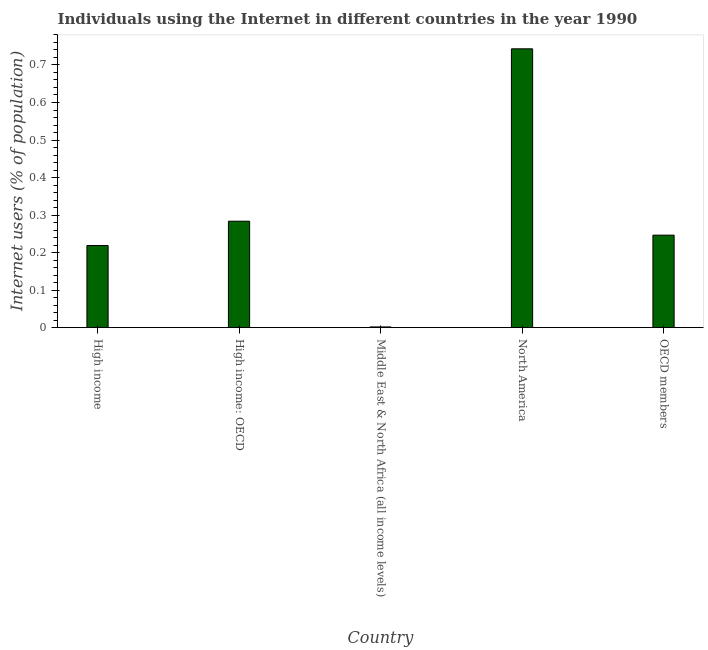Does the graph contain grids?
Make the answer very short. No. What is the title of the graph?
Give a very brief answer. Individuals using the Internet in different countries in the year 1990. What is the label or title of the X-axis?
Offer a terse response. Country. What is the label or title of the Y-axis?
Keep it short and to the point. Internet users (% of population). What is the number of internet users in Middle East & North Africa (all income levels)?
Your response must be concise. 0. Across all countries, what is the maximum number of internet users?
Ensure brevity in your answer.  0.74. Across all countries, what is the minimum number of internet users?
Keep it short and to the point. 0. In which country was the number of internet users maximum?
Offer a very short reply. North America. In which country was the number of internet users minimum?
Keep it short and to the point. Middle East & North Africa (all income levels). What is the sum of the number of internet users?
Ensure brevity in your answer.  1.49. What is the difference between the number of internet users in High income and OECD members?
Offer a terse response. -0.03. What is the average number of internet users per country?
Offer a terse response. 0.3. What is the median number of internet users?
Offer a terse response. 0.25. What is the ratio of the number of internet users in North America to that in OECD members?
Offer a very short reply. 3.01. Is the difference between the number of internet users in Middle East & North Africa (all income levels) and OECD members greater than the difference between any two countries?
Your response must be concise. No. What is the difference between the highest and the second highest number of internet users?
Offer a terse response. 0.46. What is the difference between the highest and the lowest number of internet users?
Keep it short and to the point. 0.74. Are all the bars in the graph horizontal?
Offer a very short reply. No. How many countries are there in the graph?
Provide a succinct answer. 5. What is the difference between two consecutive major ticks on the Y-axis?
Your answer should be very brief. 0.1. What is the Internet users (% of population) of High income?
Make the answer very short. 0.22. What is the Internet users (% of population) of High income: OECD?
Give a very brief answer. 0.28. What is the Internet users (% of population) in Middle East & North Africa (all income levels)?
Offer a terse response. 0. What is the Internet users (% of population) in North America?
Your answer should be very brief. 0.74. What is the Internet users (% of population) of OECD members?
Give a very brief answer. 0.25. What is the difference between the Internet users (% of population) in High income and High income: OECD?
Make the answer very short. -0.06. What is the difference between the Internet users (% of population) in High income and Middle East & North Africa (all income levels)?
Your response must be concise. 0.22. What is the difference between the Internet users (% of population) in High income and North America?
Ensure brevity in your answer.  -0.52. What is the difference between the Internet users (% of population) in High income and OECD members?
Keep it short and to the point. -0.03. What is the difference between the Internet users (% of population) in High income: OECD and Middle East & North Africa (all income levels)?
Ensure brevity in your answer.  0.28. What is the difference between the Internet users (% of population) in High income: OECD and North America?
Keep it short and to the point. -0.46. What is the difference between the Internet users (% of population) in High income: OECD and OECD members?
Give a very brief answer. 0.04. What is the difference between the Internet users (% of population) in Middle East & North Africa (all income levels) and North America?
Provide a succinct answer. -0.74. What is the difference between the Internet users (% of population) in Middle East & North Africa (all income levels) and OECD members?
Your answer should be very brief. -0.24. What is the difference between the Internet users (% of population) in North America and OECD members?
Make the answer very short. 0.5. What is the ratio of the Internet users (% of population) in High income to that in High income: OECD?
Offer a very short reply. 0.77. What is the ratio of the Internet users (% of population) in High income to that in Middle East & North Africa (all income levels)?
Offer a very short reply. 111.64. What is the ratio of the Internet users (% of population) in High income to that in North America?
Give a very brief answer. 0.29. What is the ratio of the Internet users (% of population) in High income to that in OECD members?
Give a very brief answer. 0.89. What is the ratio of the Internet users (% of population) in High income: OECD to that in Middle East & North Africa (all income levels)?
Provide a succinct answer. 144.69. What is the ratio of the Internet users (% of population) in High income: OECD to that in North America?
Make the answer very short. 0.38. What is the ratio of the Internet users (% of population) in High income: OECD to that in OECD members?
Keep it short and to the point. 1.15. What is the ratio of the Internet users (% of population) in Middle East & North Africa (all income levels) to that in North America?
Ensure brevity in your answer.  0. What is the ratio of the Internet users (% of population) in Middle East & North Africa (all income levels) to that in OECD members?
Provide a succinct answer. 0.01. What is the ratio of the Internet users (% of population) in North America to that in OECD members?
Provide a succinct answer. 3.01. 